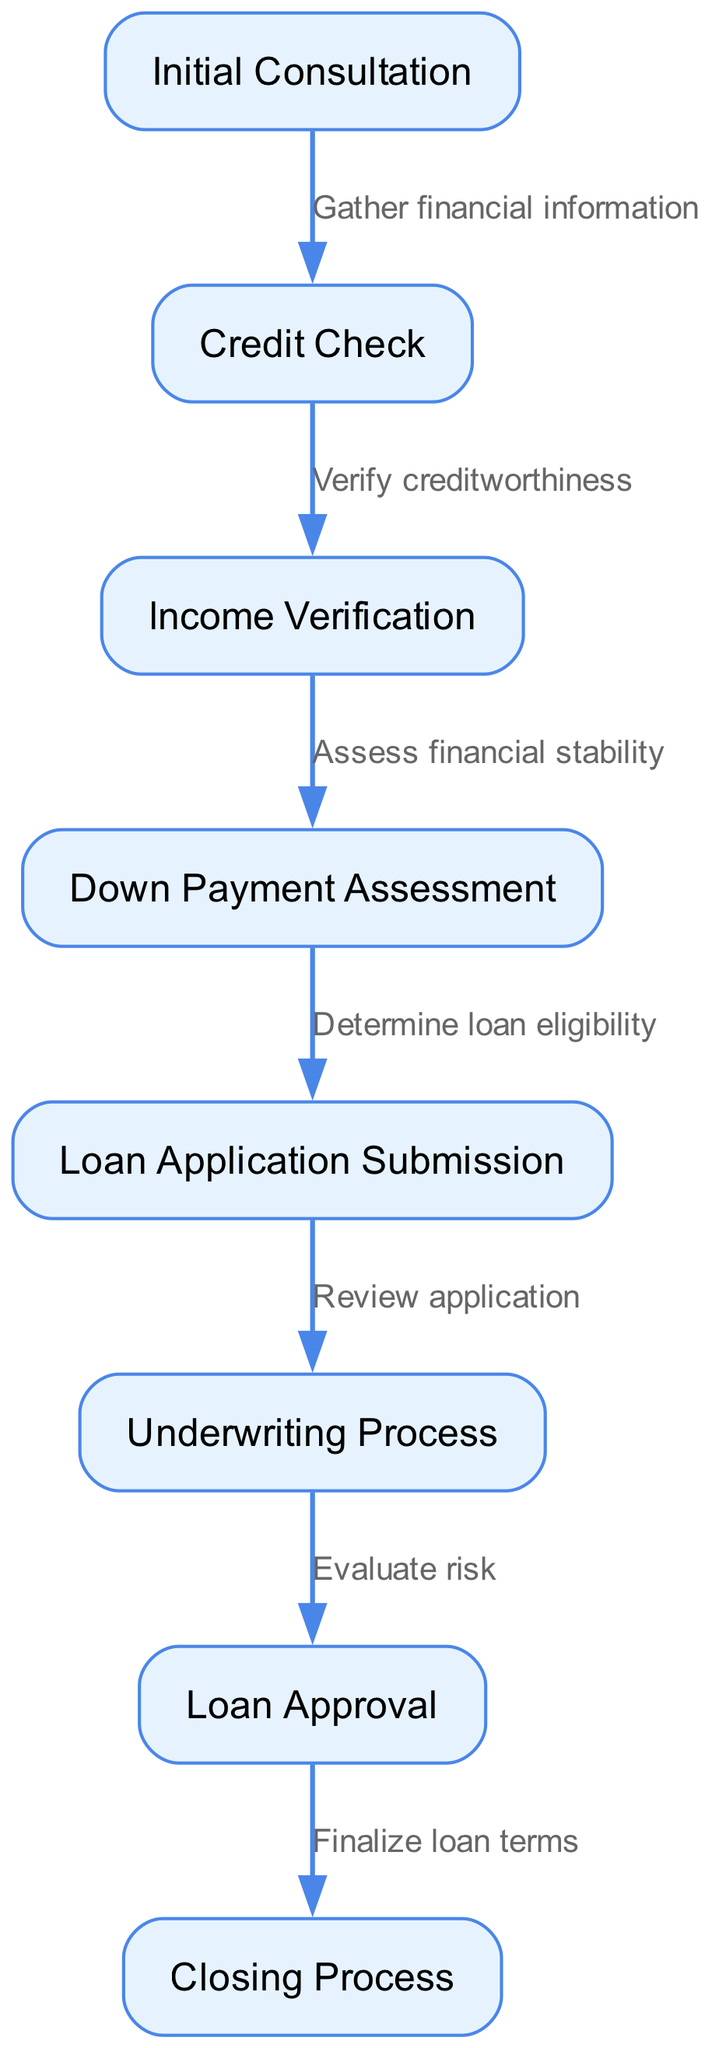What is the first step in the mortgage application process? The first step is represented by the node labeled "Initial Consultation", which is the starting point of the flow, indicating where the process begins.
Answer: Initial Consultation How many nodes are in the diagram? The diagram contains eight distinct nodes that represent different steps in the mortgage application process.
Answer: 8 What is the final step in the mortgage application process? The final step is represented by the node labeled "Closing Process", indicating the completion of the application process.
Answer: Closing Process What does the edge from "Loan Approval" to "Closing Process" signify? The edge indicates that after loan approval is achieved, the next step is to finalize the loan terms and complete the closing process, which is essential for the mortgage to be finalized.
Answer: Finalize loan terms What step comes after "Income Verification"? After "Income Verification", the next step in the flow is "Down Payment Assessment", indicating that financial stability is further assessed before proceeding.
Answer: Down Payment Assessment What is the relationship between "Credit Check" and "Income Verification"? The relationship is that the "Credit Check" node assesses the borrower's creditworthiness, which is a prerequisite before moving on to "Income Verification", reflecting a sequential dependency.
Answer: Verify creditworthiness How many edges are there connecting the nodes? The diagram has seven edges that connect the eight nodes, creating a flow from the initial consultation to the closing process.
Answer: 7 Which step assesses financial stability? "Down Payment Assessment" is the specific step that focuses on evaluating the applicant's financial stability, following the income verification.
Answer: Down Payment Assessment What process follows after "Loan Application Submission"? The process that follows is the "Underwriting Process", in which the submitted application is reviewed and risk is evaluated before approval can be granted.
Answer: Underwriting Process 